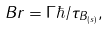<formula> <loc_0><loc_0><loc_500><loc_500>B r = \Gamma \hbar { / } \tau _ { B _ { ( s ) } } ,</formula> 